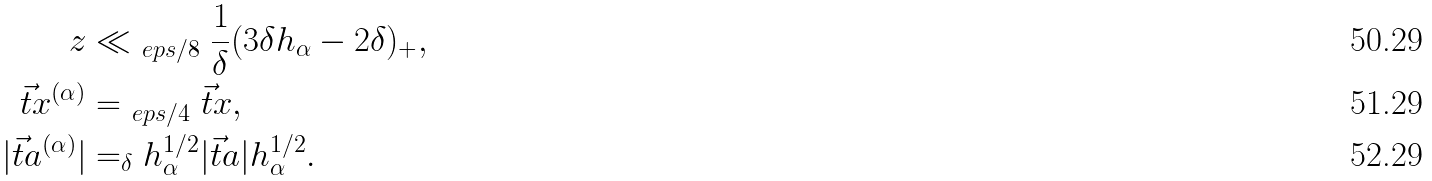<formula> <loc_0><loc_0><loc_500><loc_500>z & \ll _ { \ e p s / 8 } \frac { 1 } { \delta } ( 3 \delta h _ { \alpha } - 2 \delta ) _ { + } , \\ \vec { t } { x } ^ { ( \alpha ) } & = _ { \ e p s / 4 } \vec { t } { x } , \\ | \vec { t } { a } ^ { ( \alpha ) } | & = _ { \delta } h _ { \alpha } ^ { 1 / 2 } | \vec { t } { a } | h _ { \alpha } ^ { 1 / 2 } .</formula> 